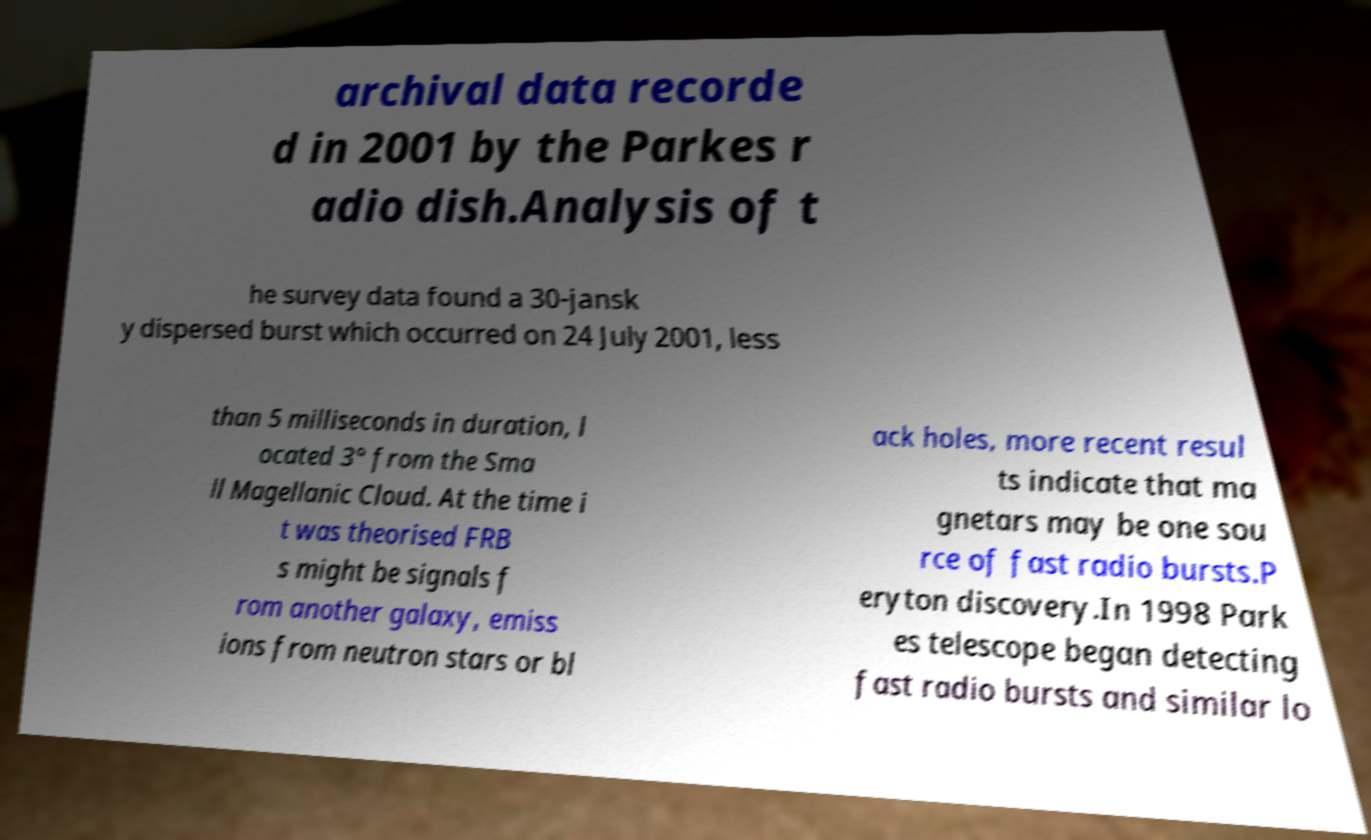Please read and relay the text visible in this image. What does it say? archival data recorde d in 2001 by the Parkes r adio dish.Analysis of t he survey data found a 30-jansk y dispersed burst which occurred on 24 July 2001, less than 5 milliseconds in duration, l ocated 3° from the Sma ll Magellanic Cloud. At the time i t was theorised FRB s might be signals f rom another galaxy, emiss ions from neutron stars or bl ack holes, more recent resul ts indicate that ma gnetars may be one sou rce of fast radio bursts.P eryton discovery.In 1998 Park es telescope began detecting fast radio bursts and similar lo 